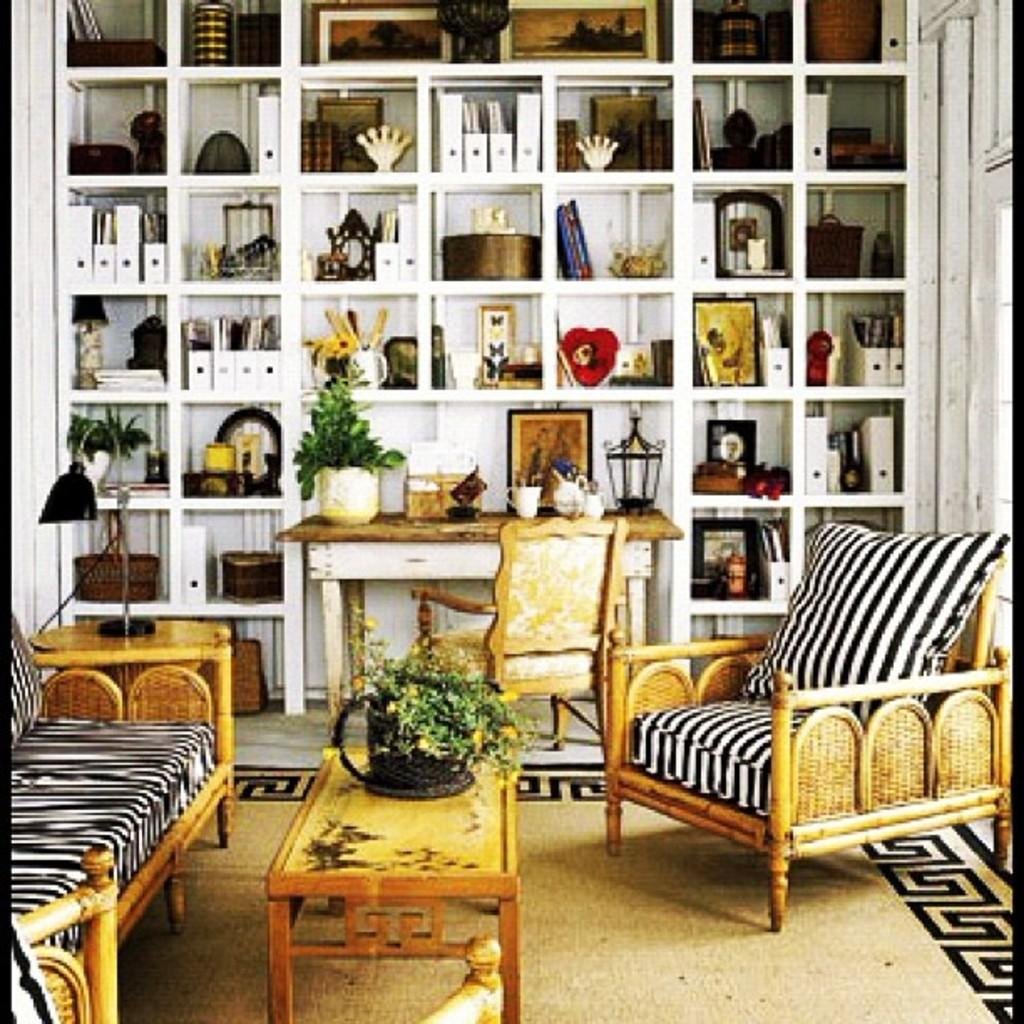What type of furniture is in the image? There is a sofa and chairs in the image. What other type of object can be seen in the image? There is a shelf in the image. What is placed on the shelf? Decorative items are present on the shelf. Where is the kitty sitting in the image? There is no kitty present in the image. What type of animal is sitting on the shelf in the image? There is no animal, such as a monkey, present on the shelf in the image. 